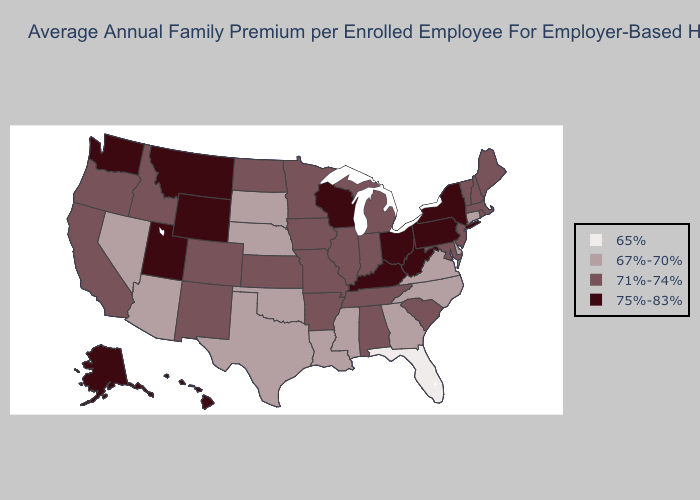What is the value of Kansas?
Answer briefly. 71%-74%. Which states have the lowest value in the USA?
Answer briefly. Florida. What is the value of Alabama?
Quick response, please. 71%-74%. Name the states that have a value in the range 75%-83%?
Be succinct. Alaska, Hawaii, Kentucky, Montana, New York, Ohio, Pennsylvania, Utah, Washington, West Virginia, Wisconsin, Wyoming. Which states have the lowest value in the USA?
Keep it brief. Florida. What is the value of Kentucky?
Answer briefly. 75%-83%. Is the legend a continuous bar?
Give a very brief answer. No. What is the lowest value in the Northeast?
Concise answer only. 67%-70%. Does the map have missing data?
Concise answer only. No. Name the states that have a value in the range 75%-83%?
Answer briefly. Alaska, Hawaii, Kentucky, Montana, New York, Ohio, Pennsylvania, Utah, Washington, West Virginia, Wisconsin, Wyoming. What is the value of South Carolina?
Short answer required. 71%-74%. Among the states that border Massachusetts , which have the lowest value?
Quick response, please. Connecticut. Among the states that border West Virginia , which have the highest value?
Write a very short answer. Kentucky, Ohio, Pennsylvania. How many symbols are there in the legend?
Short answer required. 4. Among the states that border South Dakota , does Iowa have the lowest value?
Concise answer only. No. 